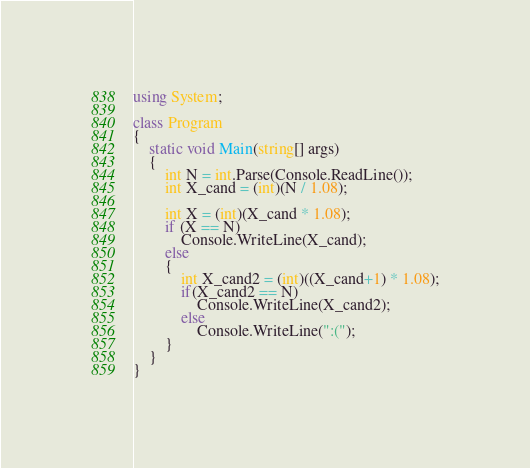<code> <loc_0><loc_0><loc_500><loc_500><_C#_>using System;

class Program
{
    static void Main(string[] args)
    {
        int N = int.Parse(Console.ReadLine());
        int X_cand = (int)(N / 1.08);

        int X = (int)(X_cand * 1.08);
        if (X == N)
            Console.WriteLine(X_cand);
        else
        {
            int X_cand2 = (int)((X_cand+1) * 1.08);
            if(X_cand2 == N)
                Console.WriteLine(X_cand2);
            else
                Console.WriteLine(":(");
        }
    }
}
</code> 